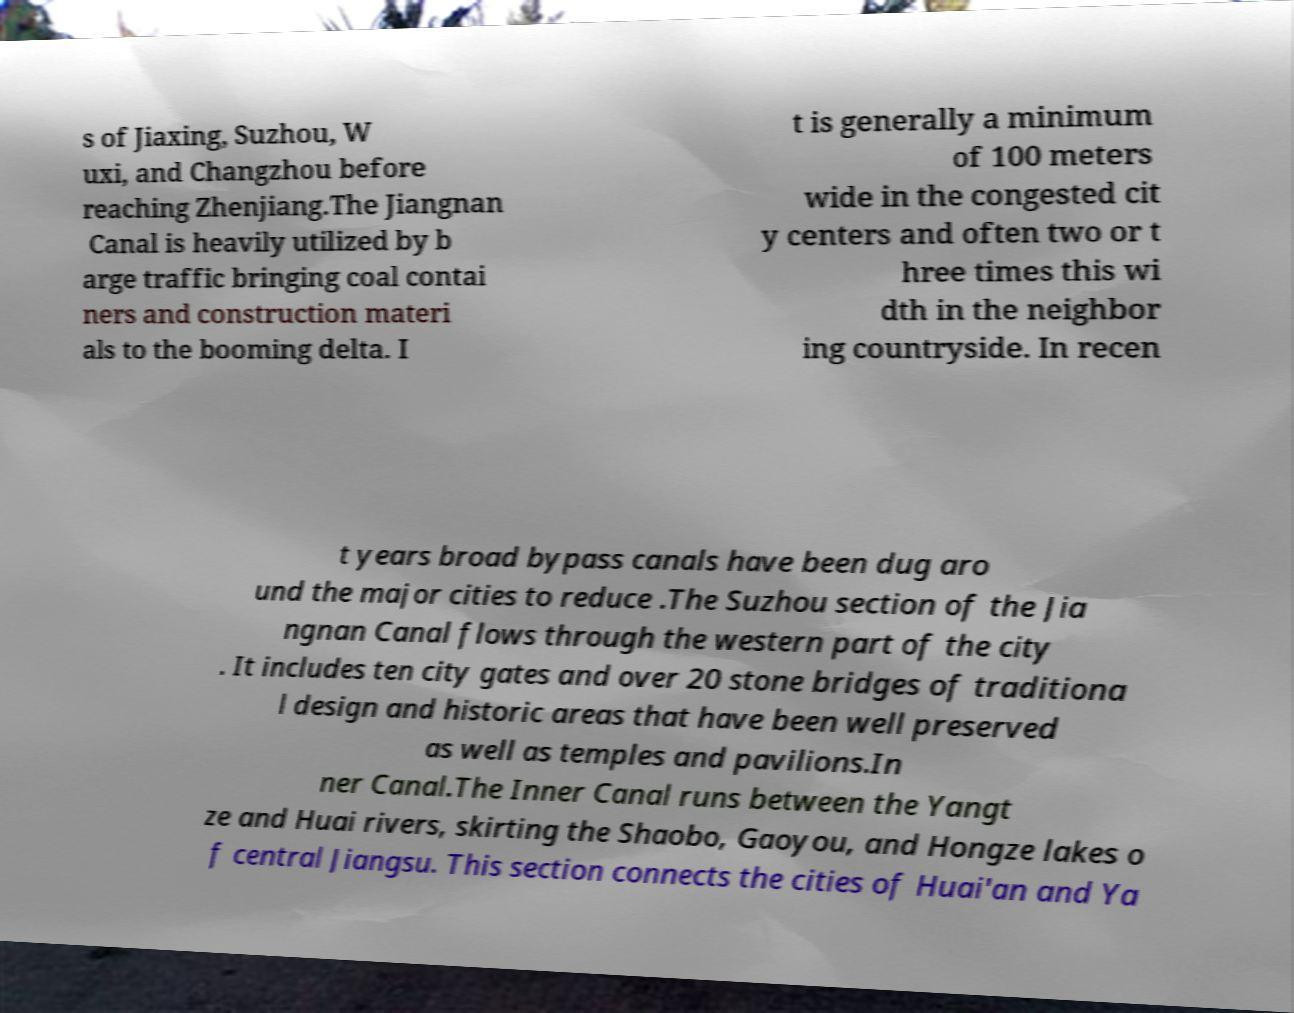Please read and relay the text visible in this image. What does it say? s of Jiaxing, Suzhou, W uxi, and Changzhou before reaching Zhenjiang.The Jiangnan Canal is heavily utilized by b arge traffic bringing coal contai ners and construction materi als to the booming delta. I t is generally a minimum of 100 meters wide in the congested cit y centers and often two or t hree times this wi dth in the neighbor ing countryside. In recen t years broad bypass canals have been dug aro und the major cities to reduce .The Suzhou section of the Jia ngnan Canal flows through the western part of the city . It includes ten city gates and over 20 stone bridges of traditiona l design and historic areas that have been well preserved as well as temples and pavilions.In ner Canal.The Inner Canal runs between the Yangt ze and Huai rivers, skirting the Shaobo, Gaoyou, and Hongze lakes o f central Jiangsu. This section connects the cities of Huai'an and Ya 